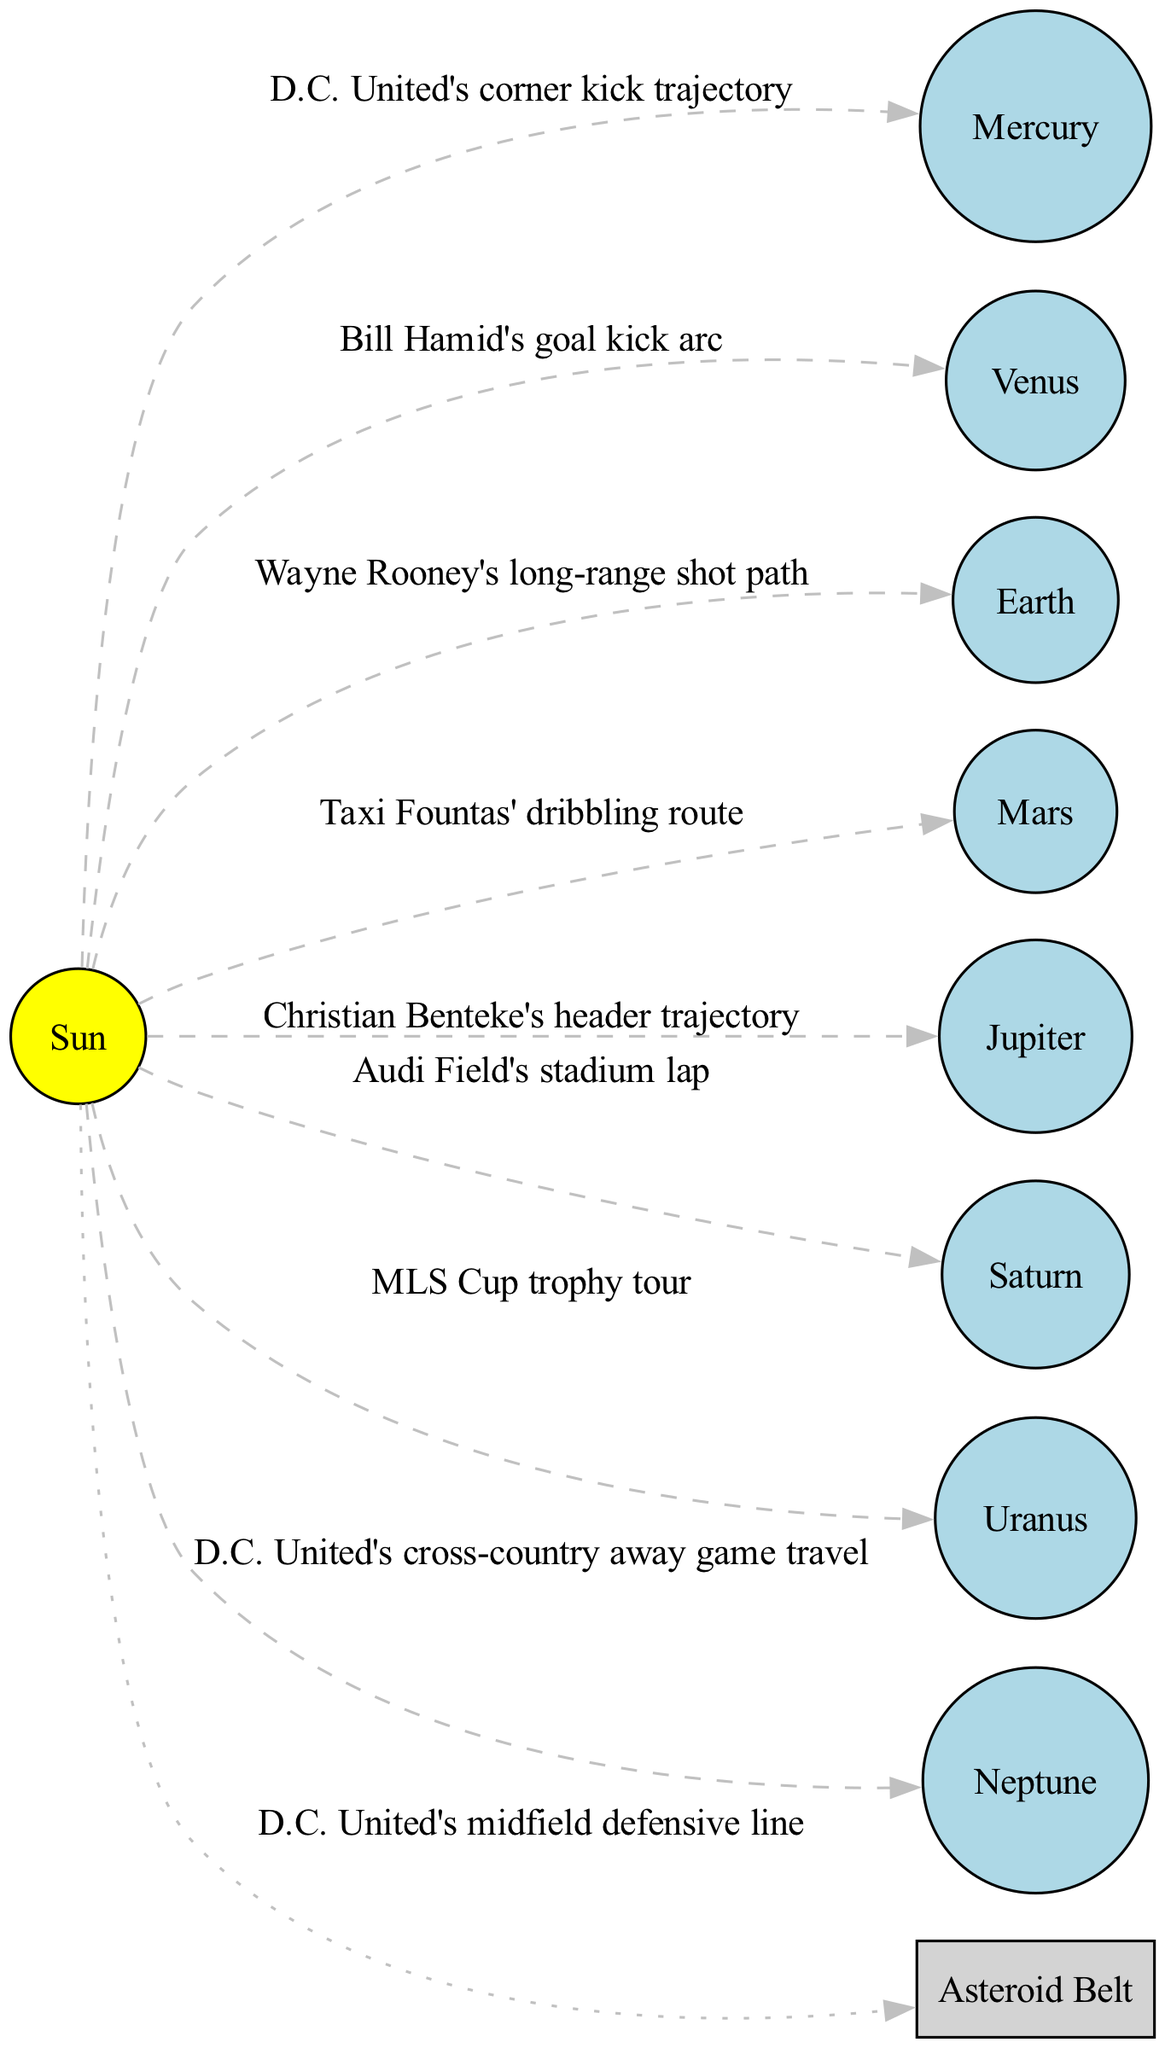What's at the center of the solar system diagram? The diagram shows the Sun at the center as the primary star of the solar system.
Answer: Sun How many planets are listed in the diagram? The diagram includes eight planets in total: Mercury, Venus, Earth, Mars, Jupiter, Saturn, Uranus, and Neptune.
Answer: 8 Which planet's orbit is represented by Wayne Rooney's long-range shot path? The orbit labeled as Wayne Rooney's long-range shot path corresponds to Earth, according to the diagram.
Answer: Earth What is the orbit of Mars represented as? The orbit of Mars is shown in the diagram as Taxi Fountas' dribbling route.
Answer: Taxi Fountas' dribbling route Which object is depicted as the Asteroid Belt? The Asteroid Belt in the diagram is depicted as a box labeled "Asteroid Belt," which represents the midfield defensive line of D.C. United.
Answer: Asteroid Belt Which planet is associated with the acronym 'MLS Cup trophy tour'? The diagram associates Uranus with the orbit representing the 'MLS Cup trophy tour.'
Answer: Uranus Which is the longest orbit path represented, and what does it correspond to? Saturn's orbit corresponds to Audi Field's stadium lap, which is highlighted as the longest orbit path in the diagram.
Answer: Audi Field's stadium lap How many edges connect the planets to the Sun? Each of the eight planets has a dashed edge connecting it to the Sun, resulting in a total of eight edges in the diagram.
Answer: 8 Which planet has the orbit linked to Christian Benteke's header? The orbit connected to Christian Benteke's header trajectory is identified as Jupiter in the diagram.
Answer: Jupiter 